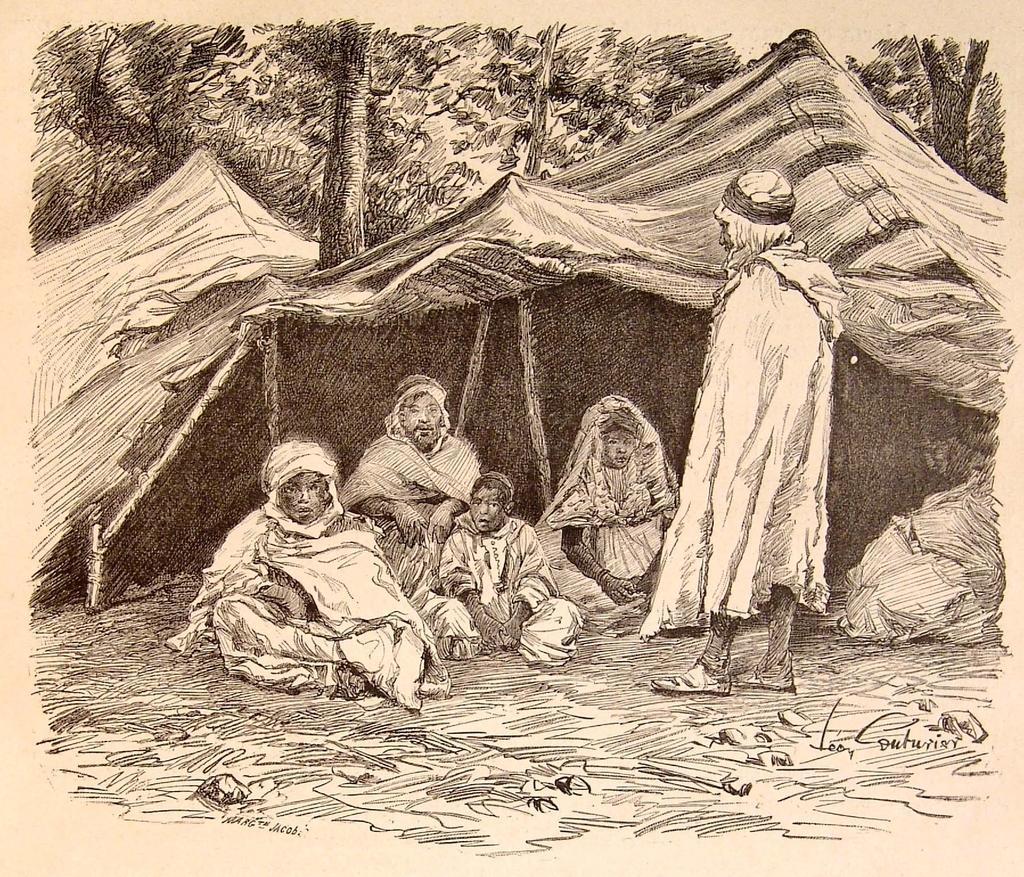Could you give a brief overview of what you see in this image? In this image we can see there is a poster with painting and there are persons, tent and trees. 